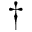Convert formula to latex. <formula><loc_0><loc_0><loc_500><loc_500>^ { \dagger }</formula> 